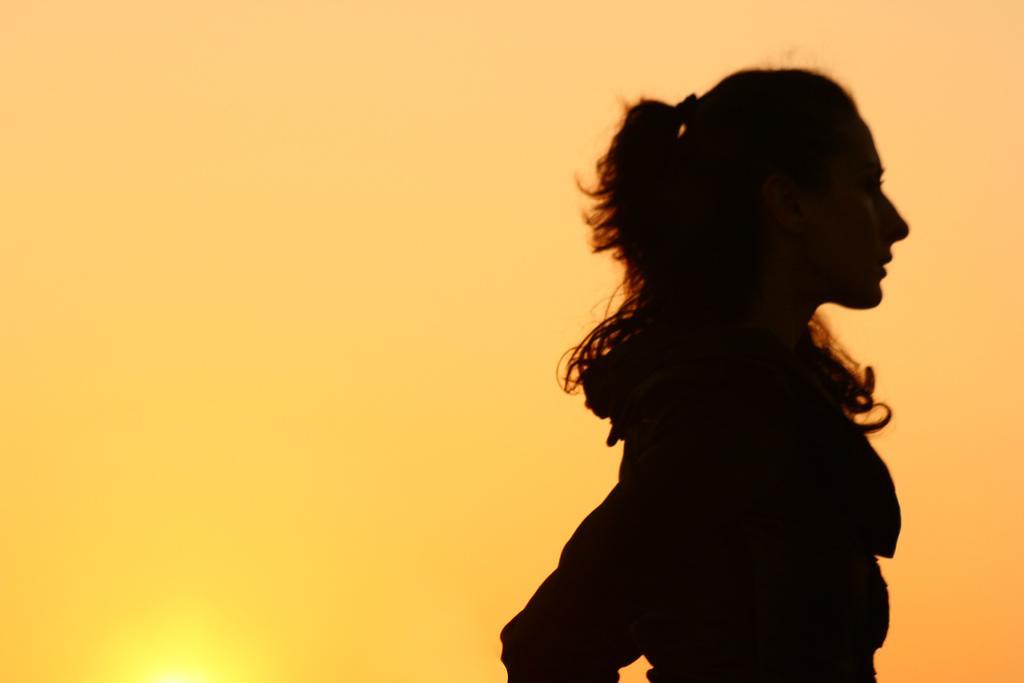Could you give a brief overview of what you see in this image? In this picture we can see a woman standing here, in the background there is the sky. 